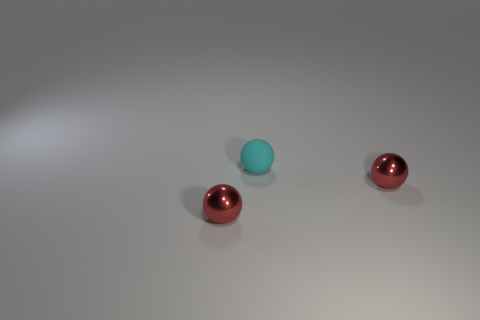Does the cyan thing have the same material as the tiny red object that is left of the small cyan sphere?
Provide a succinct answer. No. Is there a red metal ball of the same size as the cyan rubber ball?
Your answer should be compact. Yes. How many other things are the same color as the tiny rubber sphere?
Offer a terse response. 0. Are there any small red metal balls that are to the left of the red metal sphere in front of the red sphere that is right of the tiny rubber thing?
Your response must be concise. No. How many other objects are the same material as the cyan sphere?
Ensure brevity in your answer.  0. How many small objects are there?
Offer a very short reply. 3. What number of things are either shiny objects or small metal things that are in front of the small rubber object?
Your response must be concise. 2. Is there any other thing that has the same shape as the small cyan thing?
Your response must be concise. Yes. Do the sphere that is on the left side of the matte thing and the small rubber ball have the same size?
Your answer should be very brief. Yes. What number of shiny objects are small green cubes or small balls?
Make the answer very short. 2. 